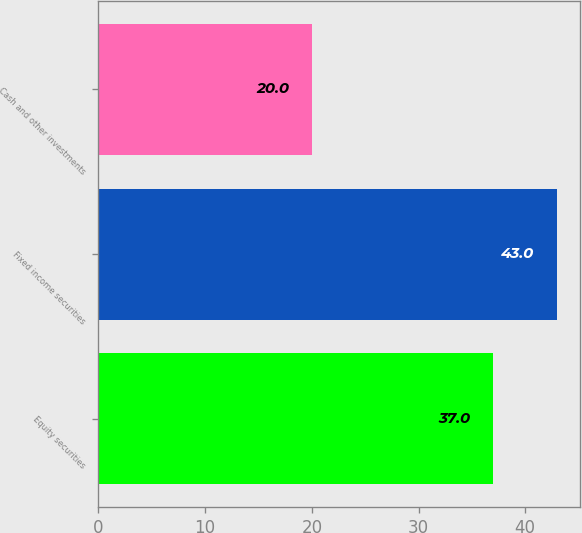<chart> <loc_0><loc_0><loc_500><loc_500><bar_chart><fcel>Equity securities<fcel>Fixed income securities<fcel>Cash and other investments<nl><fcel>37<fcel>43<fcel>20<nl></chart> 